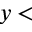<formula> <loc_0><loc_0><loc_500><loc_500>y <</formula> 